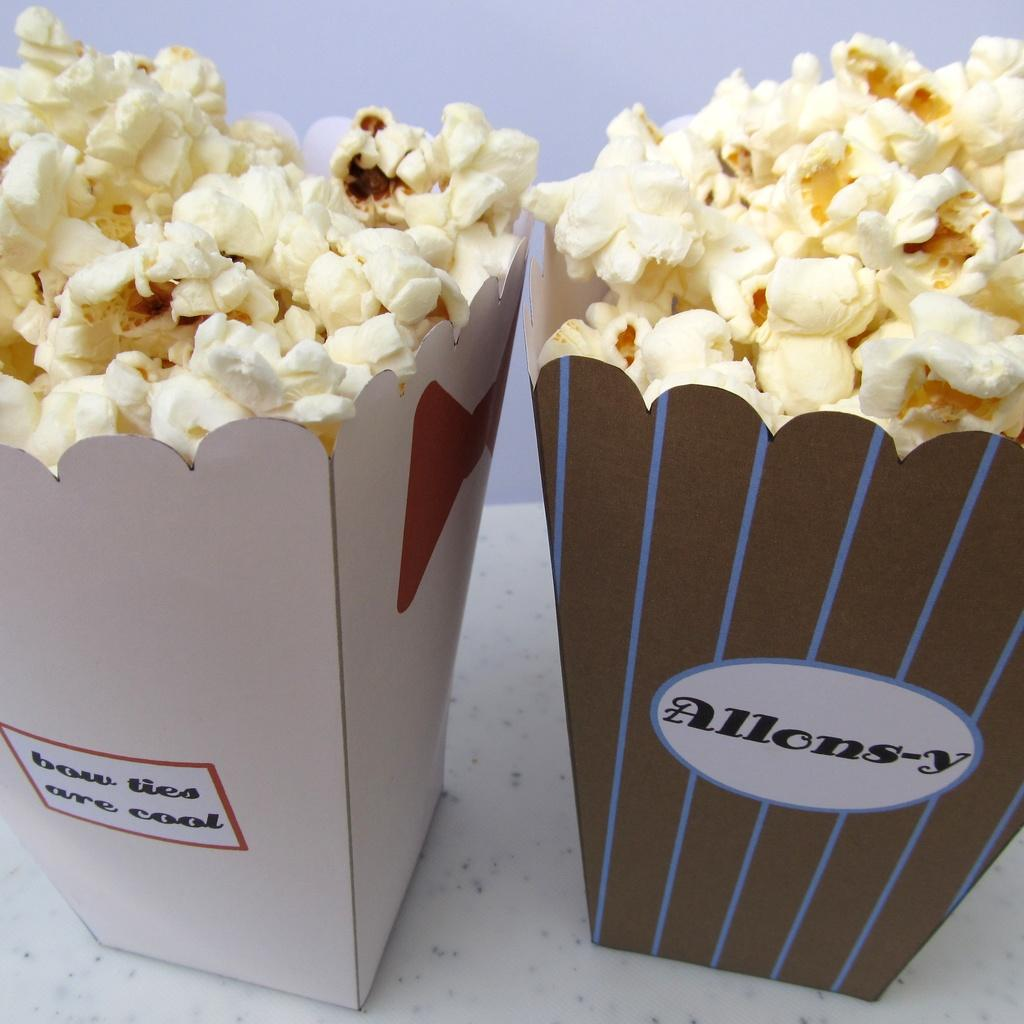What type of snack is in the foreground of the image? There are popcorn in the foreground of the image. How are the popcorn contained in the image? The popcorn are in a cardboard container. Where is the cardboard container placed in the image? The cardboard container is placed on a surface. What can be seen in the background of the image? There is a wall visible in the background of the image. What type of cave can be seen in the background of the image? There is no cave present in the image; it features a wall in the background. What is the mom doing in the image? There is no person, let alone a mom, present in the image. 